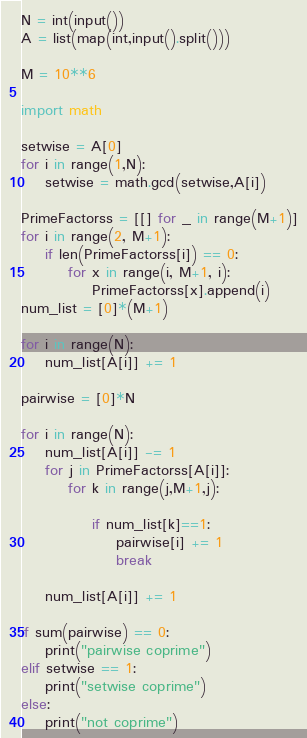<code> <loc_0><loc_0><loc_500><loc_500><_Python_>N = int(input())
A = list(map(int,input().split()))

M = 10**6

import math

setwise = A[0]
for i in range(1,N):
    setwise = math.gcd(setwise,A[i])
    
PrimeFactorss = [[] for _ in range(M+1)]
for i in range(2, M+1):
    if len(PrimeFactorss[i]) == 0:
        for x in range(i, M+1, i):
            PrimeFactorss[x].append(i)
num_list = [0]*(M+1)

for i in range(N):
    num_list[A[i]] += 1

pairwise = [0]*N

for i in range(N):
    num_list[A[i]] -= 1
    for j in PrimeFactorss[A[i]]:
        for k in range(j,M+1,j):

            if num_list[k]==1:
                pairwise[i] += 1
                break
                
    num_list[A[i]] += 1
    
if sum(pairwise) == 0:
    print("pairwise coprime")
elif setwise == 1:
    print("setwise coprime")
else:
    print("not coprime")
</code> 